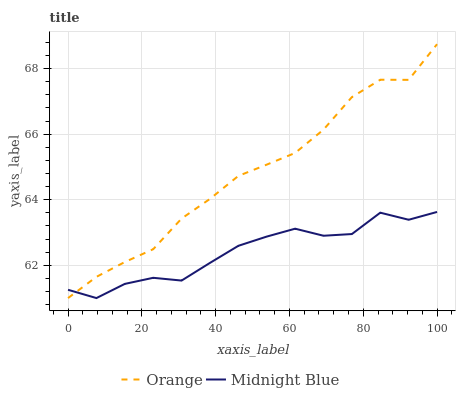Does Midnight Blue have the minimum area under the curve?
Answer yes or no. Yes. Does Orange have the maximum area under the curve?
Answer yes or no. Yes. Does Midnight Blue have the maximum area under the curve?
Answer yes or no. No. Is Orange the smoothest?
Answer yes or no. Yes. Is Midnight Blue the roughest?
Answer yes or no. Yes. Is Midnight Blue the smoothest?
Answer yes or no. No. Does Orange have the highest value?
Answer yes or no. Yes. Does Midnight Blue have the highest value?
Answer yes or no. No. Does Midnight Blue intersect Orange?
Answer yes or no. Yes. Is Midnight Blue less than Orange?
Answer yes or no. No. Is Midnight Blue greater than Orange?
Answer yes or no. No. 